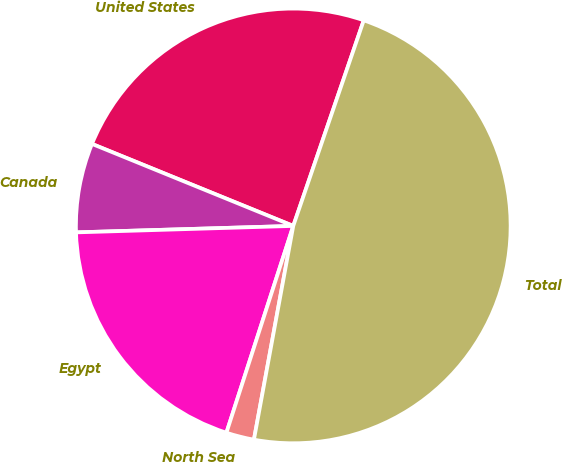Convert chart to OTSL. <chart><loc_0><loc_0><loc_500><loc_500><pie_chart><fcel>United States<fcel>Canada<fcel>Egypt<fcel>North Sea<fcel>Total<nl><fcel>24.1%<fcel>6.63%<fcel>19.55%<fcel>2.08%<fcel>47.64%<nl></chart> 